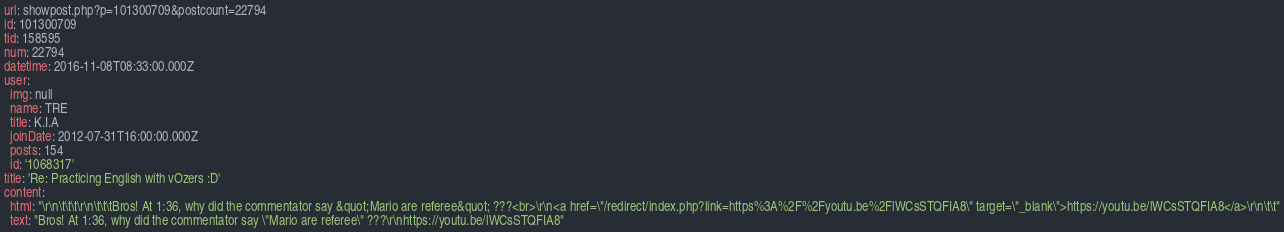<code> <loc_0><loc_0><loc_500><loc_500><_YAML_>url: showpost.php?p=101300709&postcount=22794
id: 101300709
tid: 158595
num: 22794
datetime: 2016-11-08T08:33:00.000Z
user:
  img: null
  name: TRE
  title: K.I.A
  joinDate: 2012-07-31T16:00:00.000Z
  posts: 154
  id: '1068317'
title: 'Re: Practicing English with vOzers :D'
content:
  html: "\r\n\t\t\t\r\n\t\t\tBros! At 1:36, why did the commentator say &quot;Mario are referee&quot; ???<br>\r\n<a href=\"/redirect/index.php?link=https%3A%2F%2Fyoutu.be%2FlWCsSTQFIA8\" target=\"_blank\">https://youtu.be/lWCsSTQFIA8</a>\r\n\t\t"
  text: "Bros! At 1:36, why did the commentator say \"Mario are referee\" ???\r\nhttps://youtu.be/lWCsSTQFIA8"
</code> 